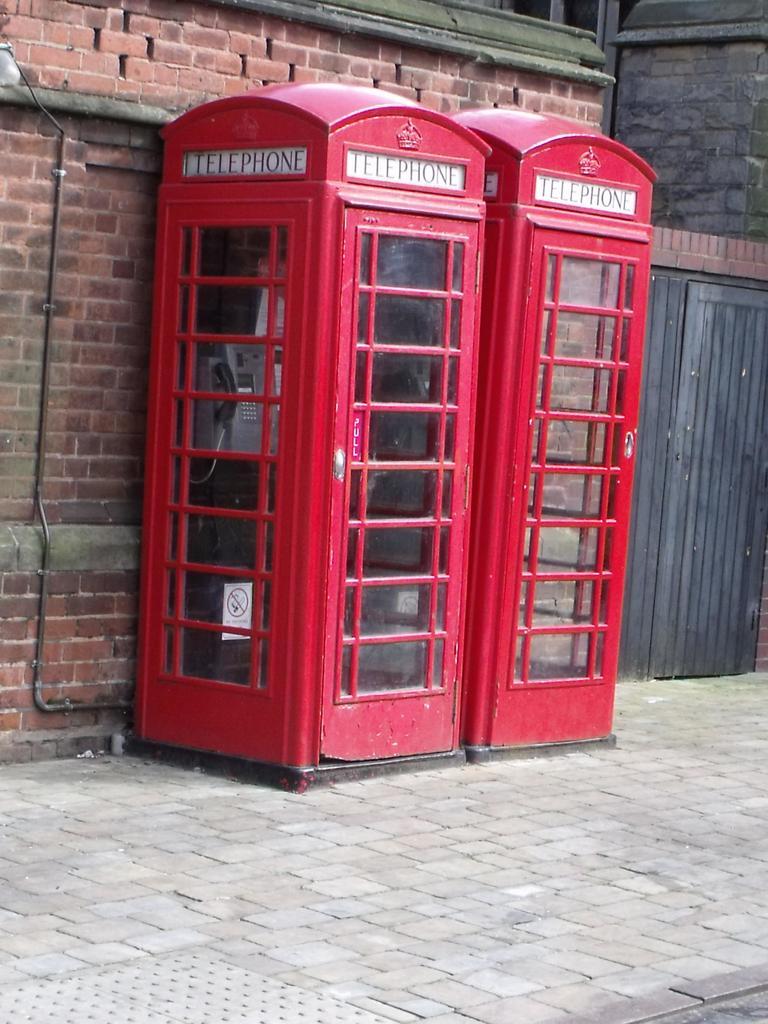What is in the red booth?
Your response must be concise. Telephone. What does it say on the top of the red booth?
Ensure brevity in your answer.  Telephone. 